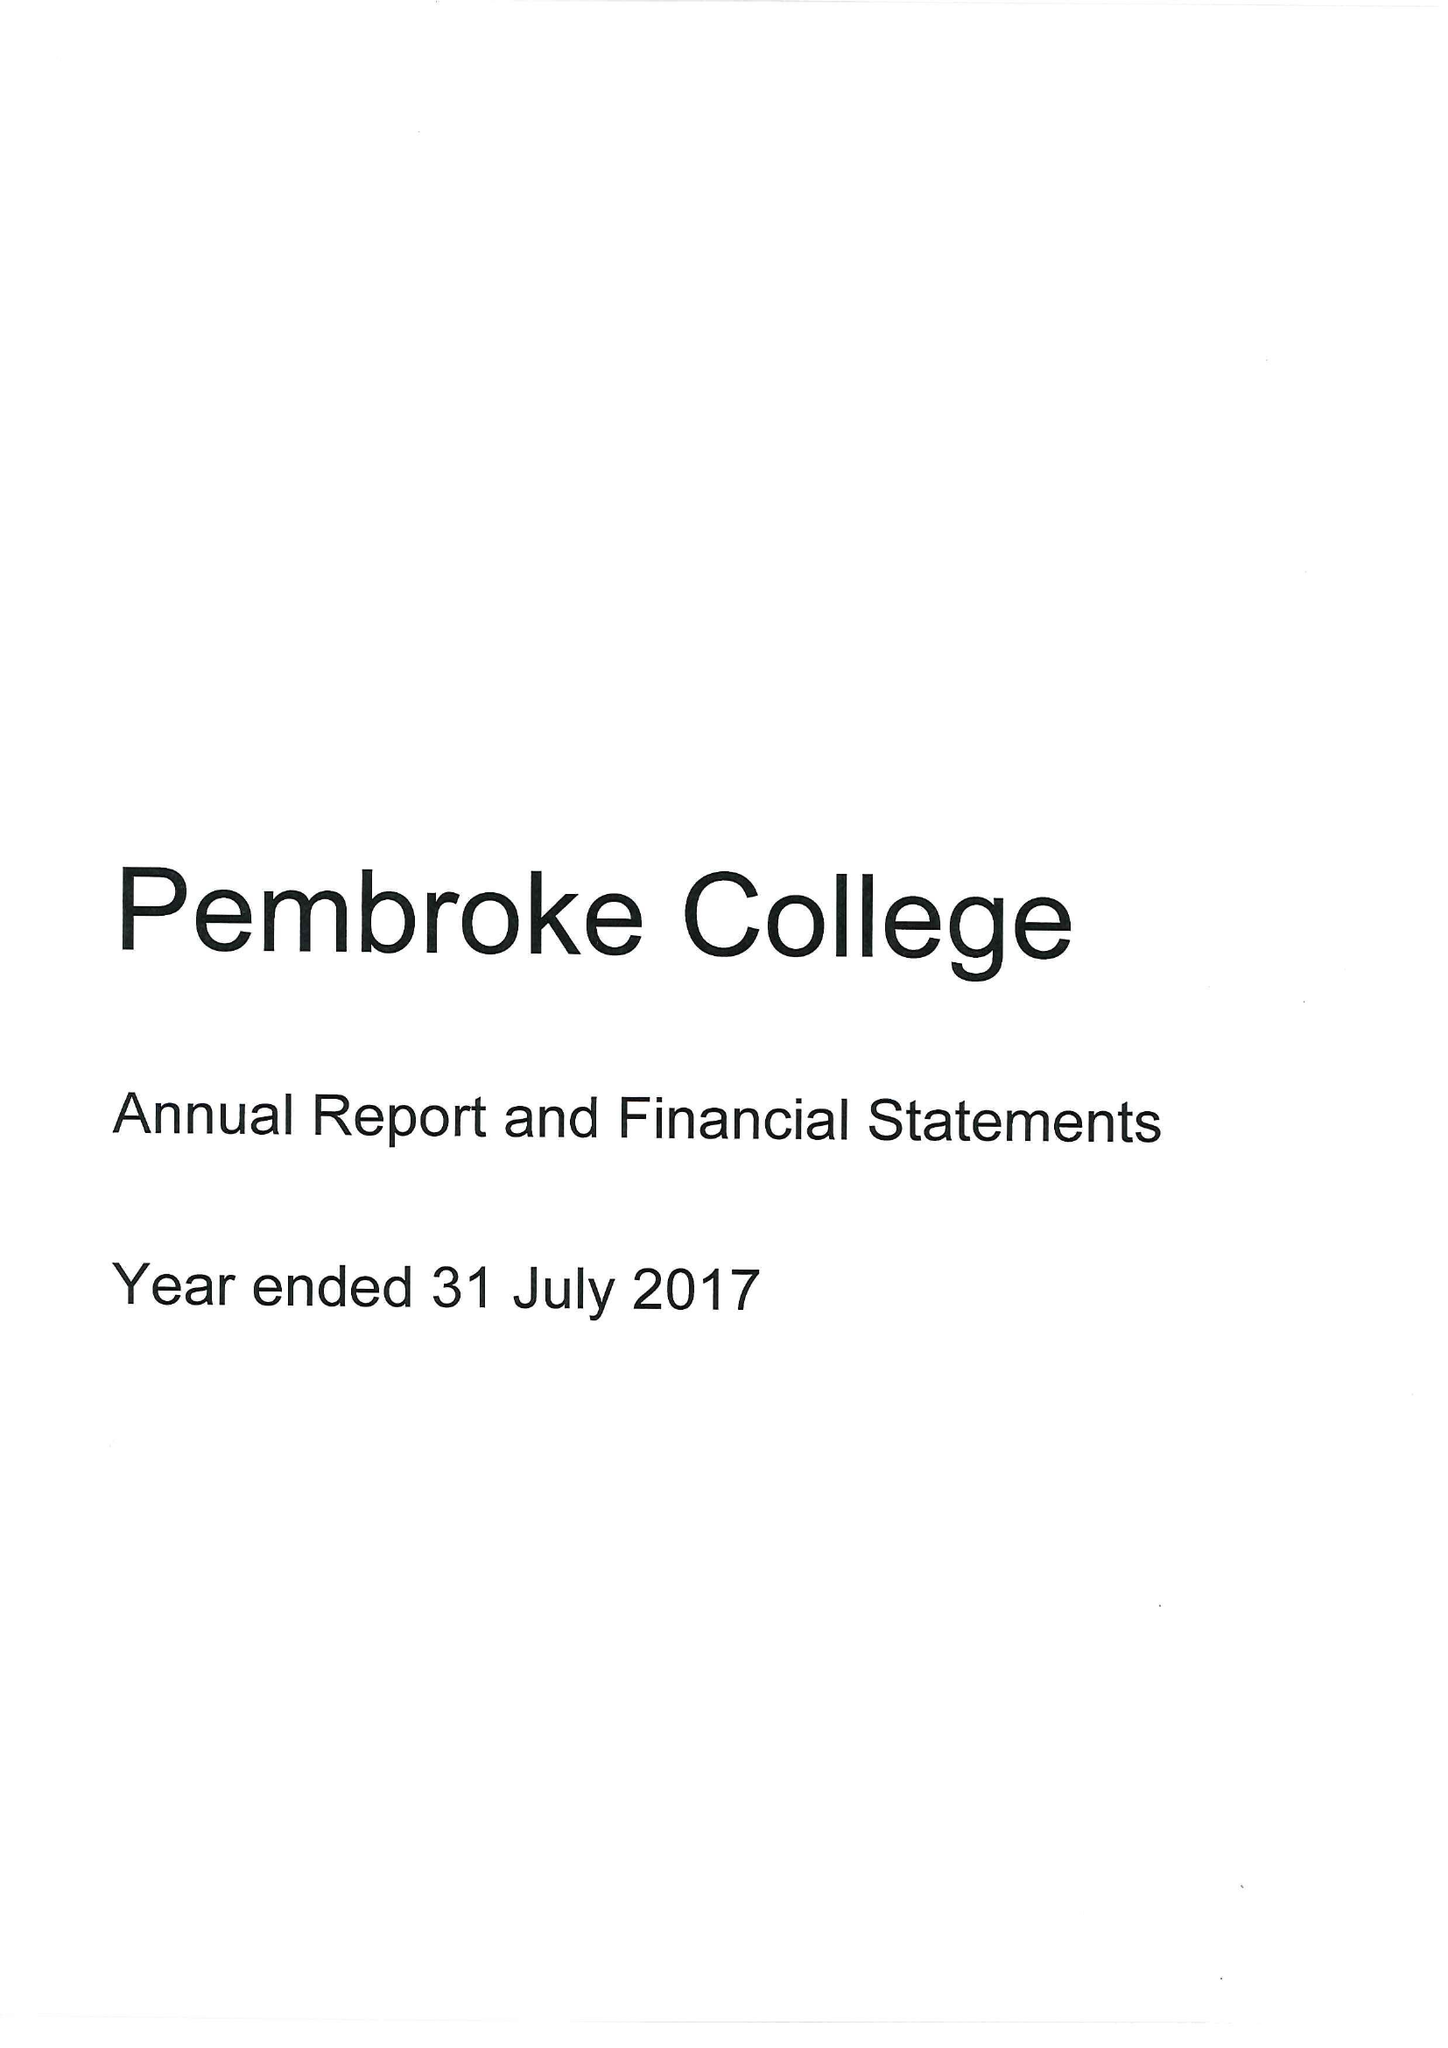What is the value for the spending_annually_in_british_pounds?
Answer the question using a single word or phrase. 11352000.00 